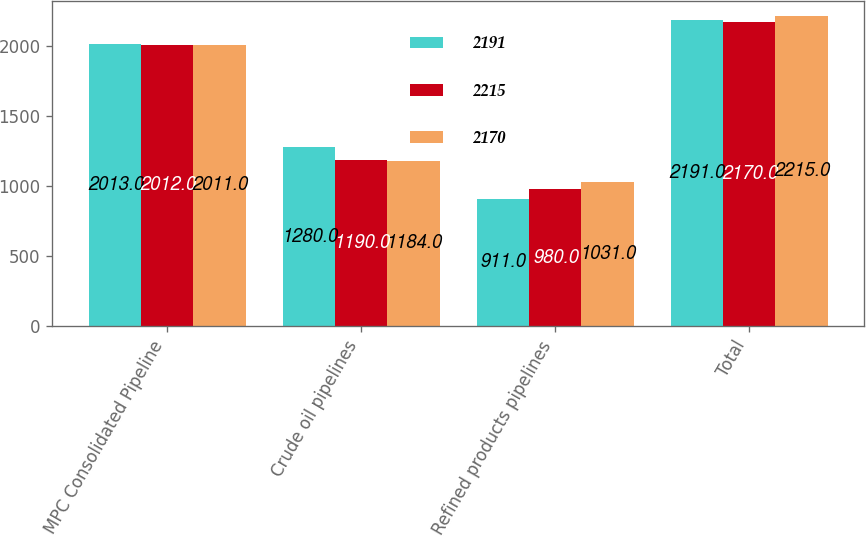<chart> <loc_0><loc_0><loc_500><loc_500><stacked_bar_chart><ecel><fcel>MPC Consolidated Pipeline<fcel>Crude oil pipelines<fcel>Refined products pipelines<fcel>Total<nl><fcel>2191<fcel>2013<fcel>1280<fcel>911<fcel>2191<nl><fcel>2215<fcel>2012<fcel>1190<fcel>980<fcel>2170<nl><fcel>2170<fcel>2011<fcel>1184<fcel>1031<fcel>2215<nl></chart> 